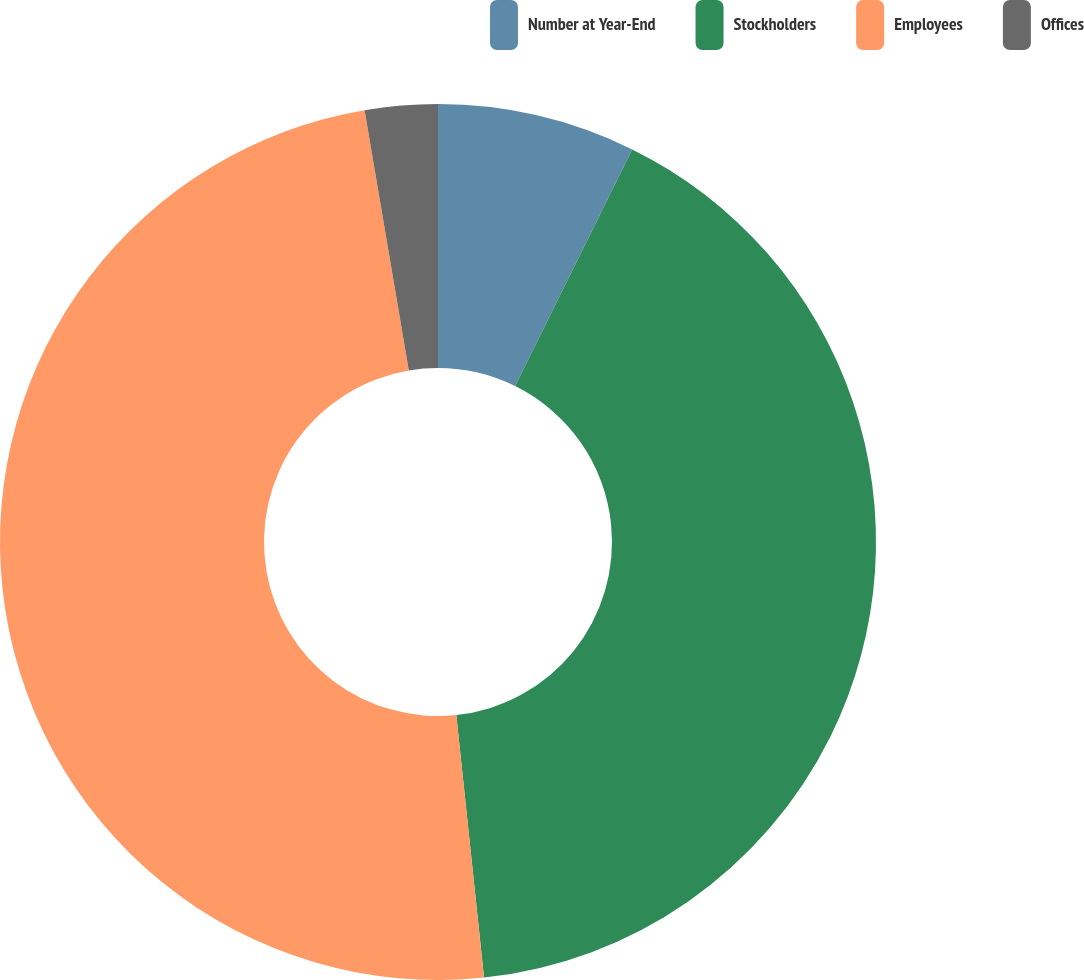Convert chart. <chart><loc_0><loc_0><loc_500><loc_500><pie_chart><fcel>Number at Year-End<fcel>Stockholders<fcel>Employees<fcel>Offices<nl><fcel>7.31%<fcel>41.01%<fcel>48.99%<fcel>2.68%<nl></chart> 